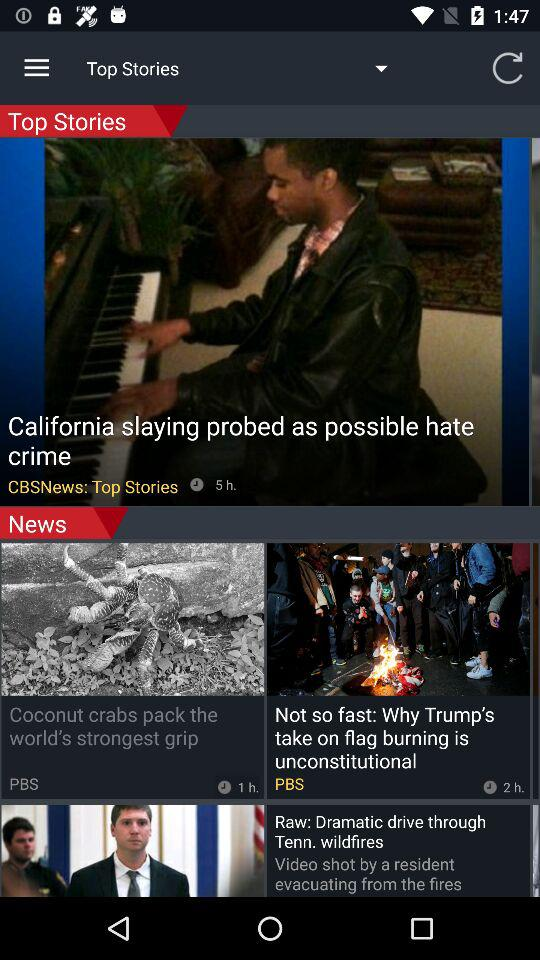What is the name of the news channel? The name of the news channel is "CBSNews". 